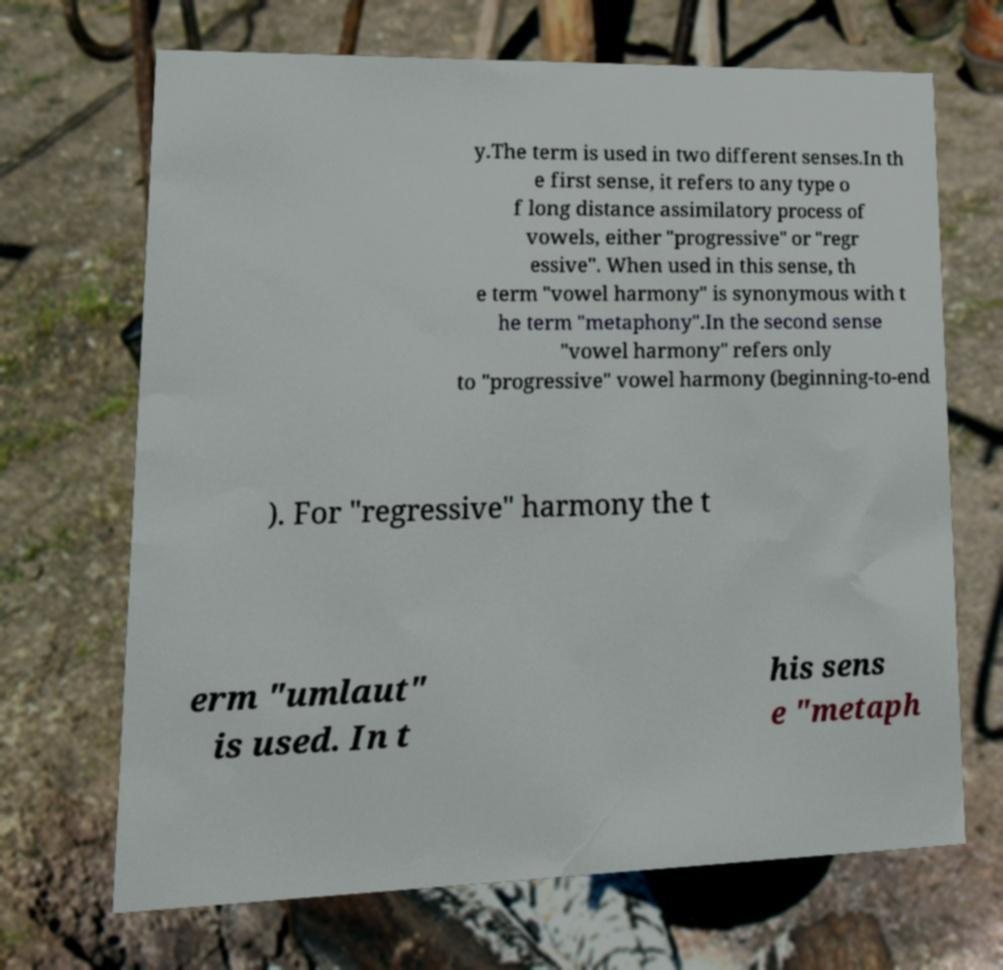Could you extract and type out the text from this image? y.The term is used in two different senses.In th e first sense, it refers to any type o f long distance assimilatory process of vowels, either "progressive" or "regr essive". When used in this sense, th e term "vowel harmony" is synonymous with t he term "metaphony".In the second sense "vowel harmony" refers only to "progressive" vowel harmony (beginning-to-end ). For "regressive" harmony the t erm "umlaut" is used. In t his sens e "metaph 